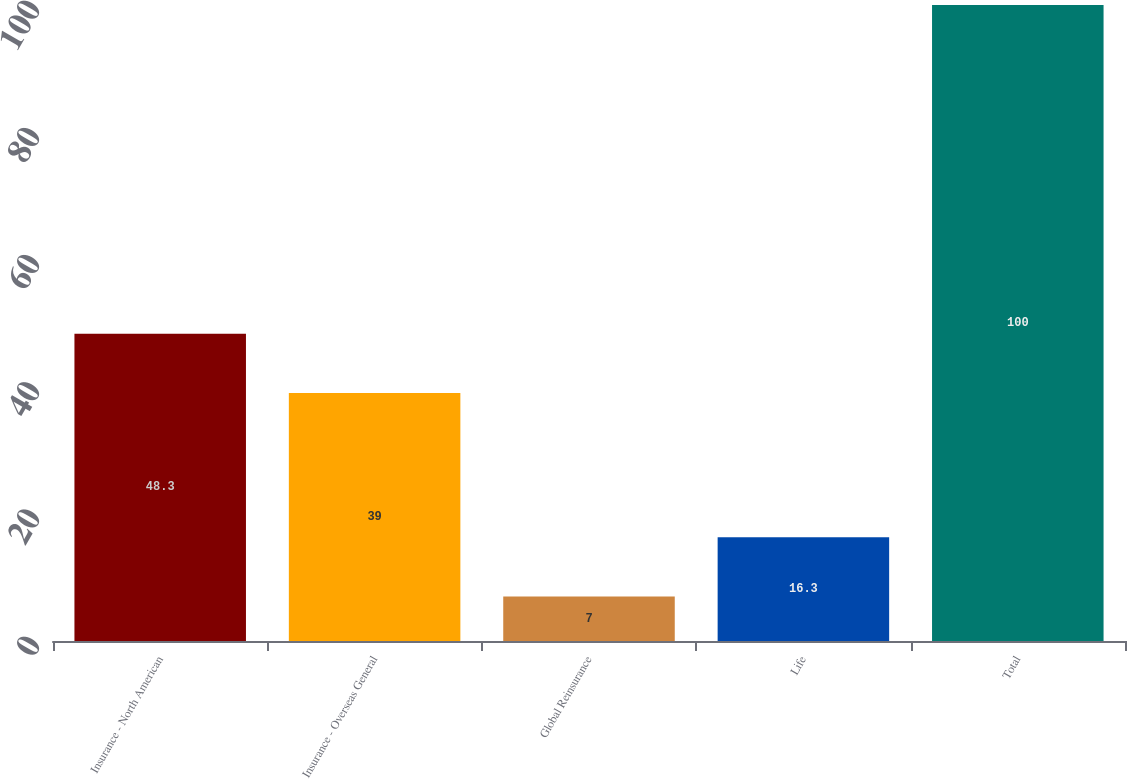<chart> <loc_0><loc_0><loc_500><loc_500><bar_chart><fcel>Insurance - North American<fcel>Insurance - Overseas General<fcel>Global Reinsurance<fcel>Life<fcel>Total<nl><fcel>48.3<fcel>39<fcel>7<fcel>16.3<fcel>100<nl></chart> 